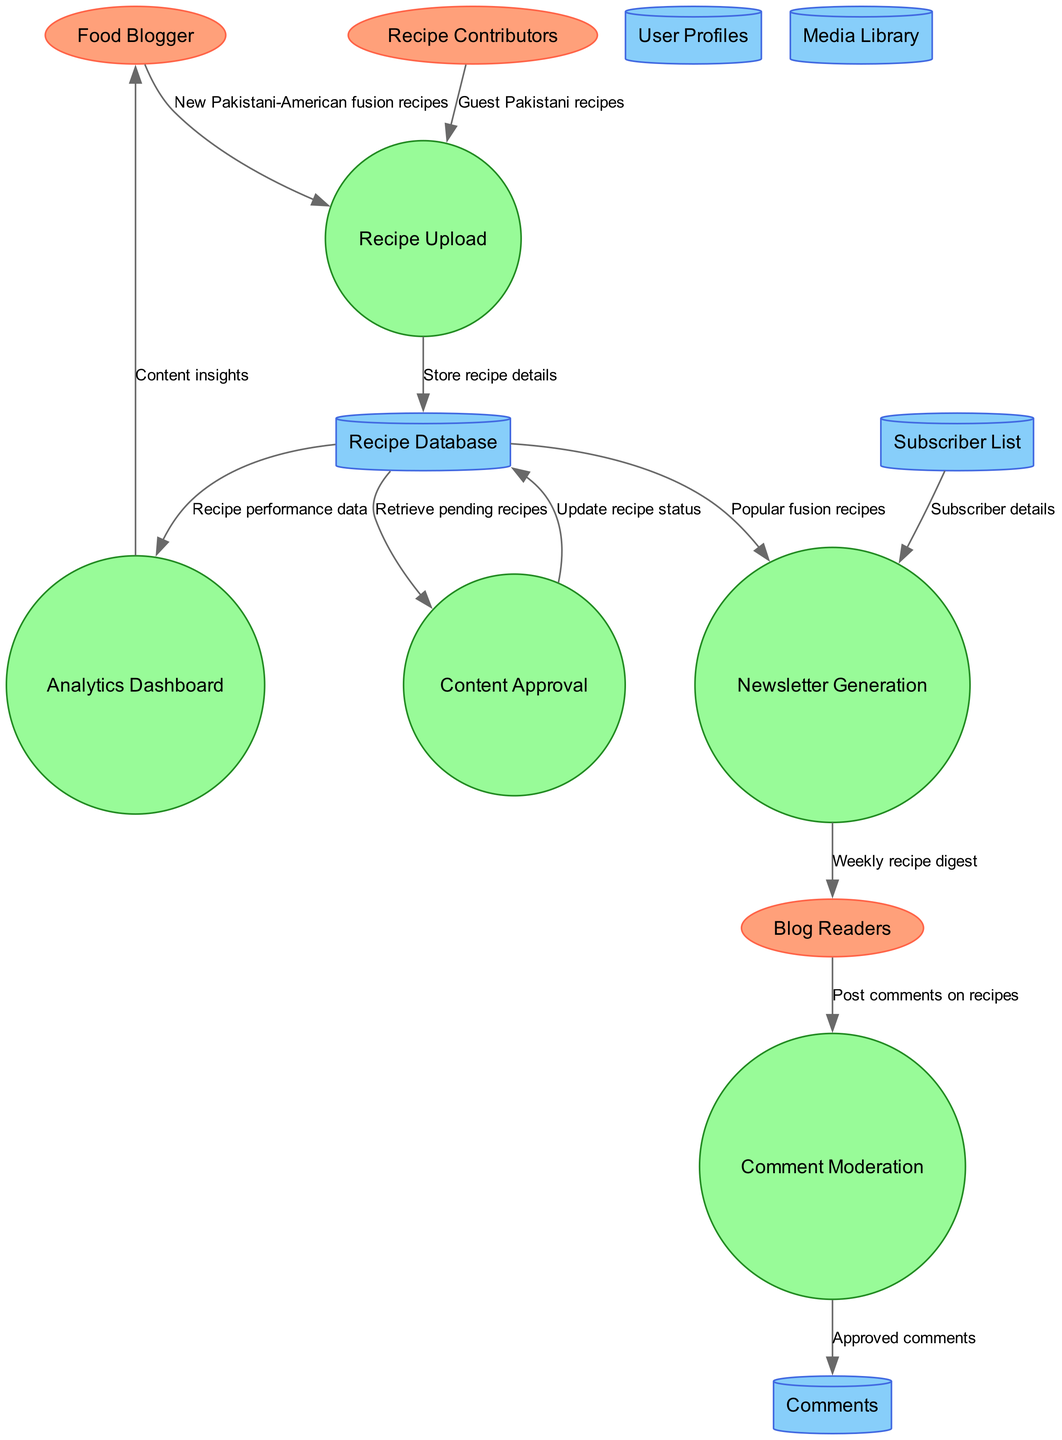What are the external entities involved in the system? The diagram shows three external entities: Food Blogger, Blog Readers, and Recipe Contributors. Each entity is represented as an ellipse, indicating their role outside the main processes.
Answer: Food Blogger, Blog Readers, Recipe Contributors How many processes are present in the diagram? There are five processes depicted in the diagram: Recipe Upload, Content Approval, Comment Moderation, Analytics Dashboard, and Newsletter Generation. Each process is in a circular shape, indicating tasks carried out in the system.
Answer: Five What does the Food Blogger provide to the Recipe Upload process? The Food Blogger provides "New Pakistani-American fusion recipes" to the Recipe Upload process, indicating the type of content submitted for upload. This flow is labeled accordingly in the diagram.
Answer: New Pakistani-American fusion recipes What type of data store holds the details of comments? Comments are stored in the "Comments" data store, defined as a cylinder shape in the diagram. Data stores are used to represent storage locations for information.
Answer: Comments Which process receives recipe performance data from the Recipe Database? The Analytics Dashboard receives the recipe performance data from the Recipe Database. The data flow indicates that it retrieves relevant performance metrics for analysis.
Answer: Analytics Dashboard How do Blog Readers interact with the Comment Moderation process? Blog Readers post comments on recipes which then flow to the Comment Moderation process for approval. This interaction is depicted in the data flow labeled as "Post comments on recipes."
Answer: Post comments on recipes What is generated from the Subscriber List data store? The Subscriber List data store generates the "Subscriber details" which is utilized in the Newsletter Generation process. This flow defines how subscriber information is accessed for creating newsletters.
Answer: Subscriber details Which process does the Analytics Dashboard provide content insights to? The Analytics Dashboard provides content insights to the Food Blogger after processing recipe performance data. This flow showcases how feedback on content is communicated back to the blogger.
Answer: Food Blogger What type of recipes are contributed by Recipe Contributors? The Recipe Contributors offer "Guest Pakistani recipes" to the Recipe Upload process. This indicates their role in contributing additional content to the food blog.
Answer: Guest Pakistani recipes 